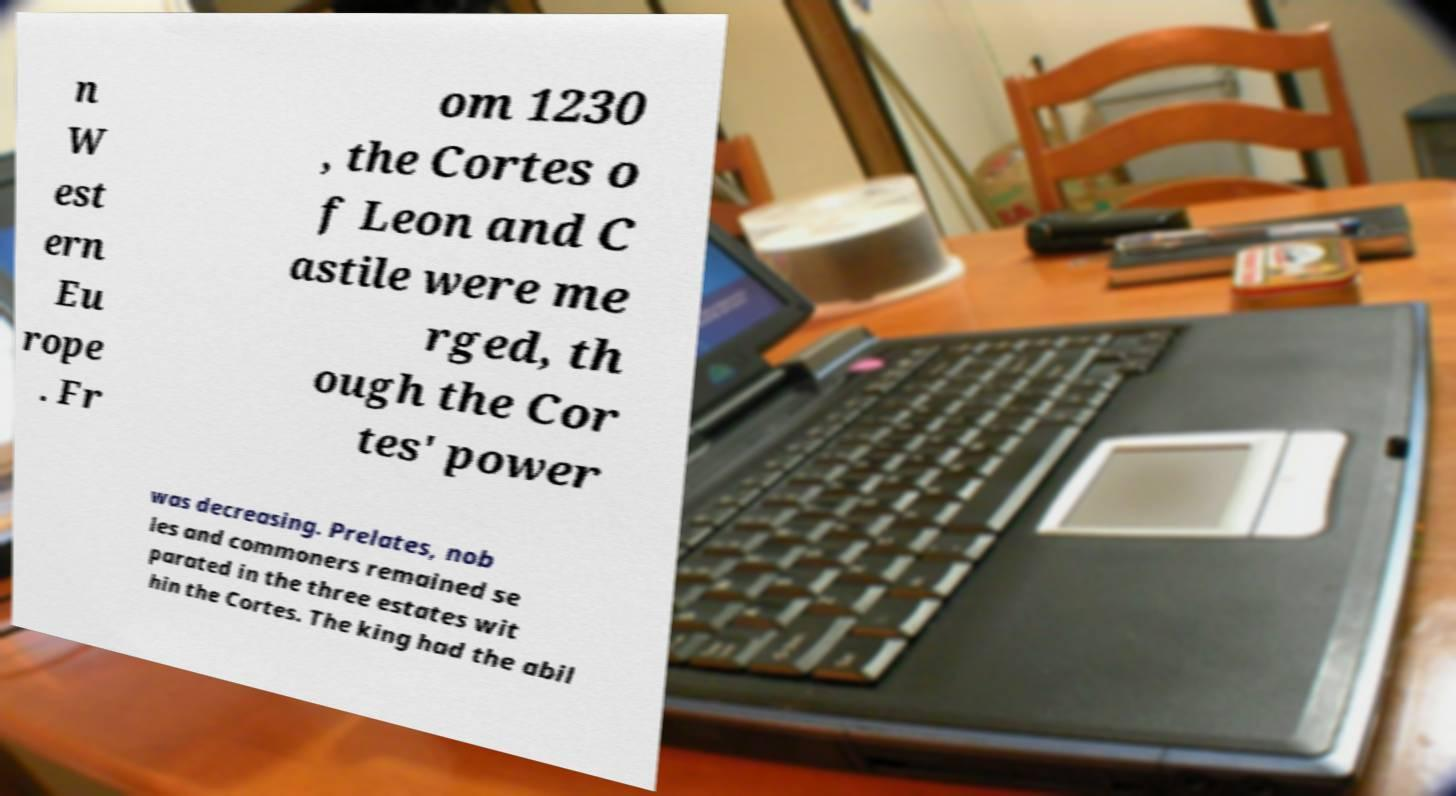There's text embedded in this image that I need extracted. Can you transcribe it verbatim? n W est ern Eu rope . Fr om 1230 , the Cortes o f Leon and C astile were me rged, th ough the Cor tes' power was decreasing. Prelates, nob les and commoners remained se parated in the three estates wit hin the Cortes. The king had the abil 